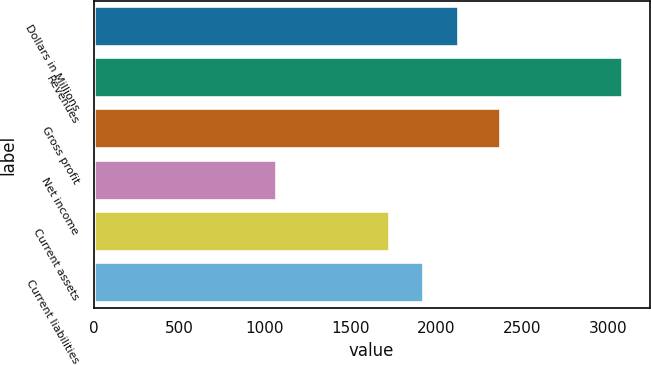Convert chart. <chart><loc_0><loc_0><loc_500><loc_500><bar_chart><fcel>Dollars in Millions<fcel>Revenues<fcel>Gross profit<fcel>Net income<fcel>Current assets<fcel>Current liabilities<nl><fcel>2131<fcel>3090<fcel>2379<fcel>1070<fcel>1727<fcel>1929<nl></chart> 